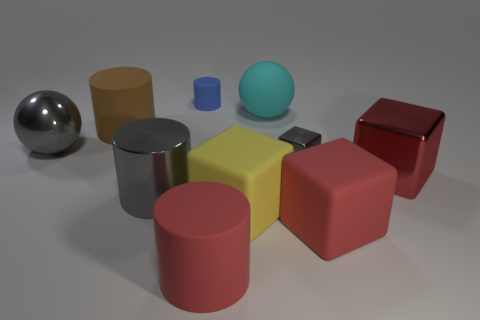There is a gray metal thing that is the same shape as the brown matte thing; what is its size?
Make the answer very short. Large. Are there more blue cylinders that are on the left side of the brown rubber object than large shiny spheres?
Make the answer very short. No. Is the ball that is to the left of the yellow rubber object made of the same material as the big gray cylinder?
Offer a very short reply. Yes. How big is the blue rubber thing that is behind the large rubber object left of the cylinder behind the cyan matte object?
Offer a terse response. Small. There is a blue cylinder that is made of the same material as the yellow cube; what size is it?
Provide a succinct answer. Small. What color is the cylinder that is behind the red rubber cylinder and in front of the gray sphere?
Offer a terse response. Gray. There is a tiny object in front of the gray metallic sphere; is it the same shape as the big matte object that is on the left side of the blue cylinder?
Keep it short and to the point. No. What is the material of the gray thing that is right of the small blue cylinder?
Provide a short and direct response. Metal. There is a cylinder that is the same color as the shiny sphere; what size is it?
Your response must be concise. Large. What number of objects are matte things that are in front of the red rubber block or tiny matte cylinders?
Your response must be concise. 2. 